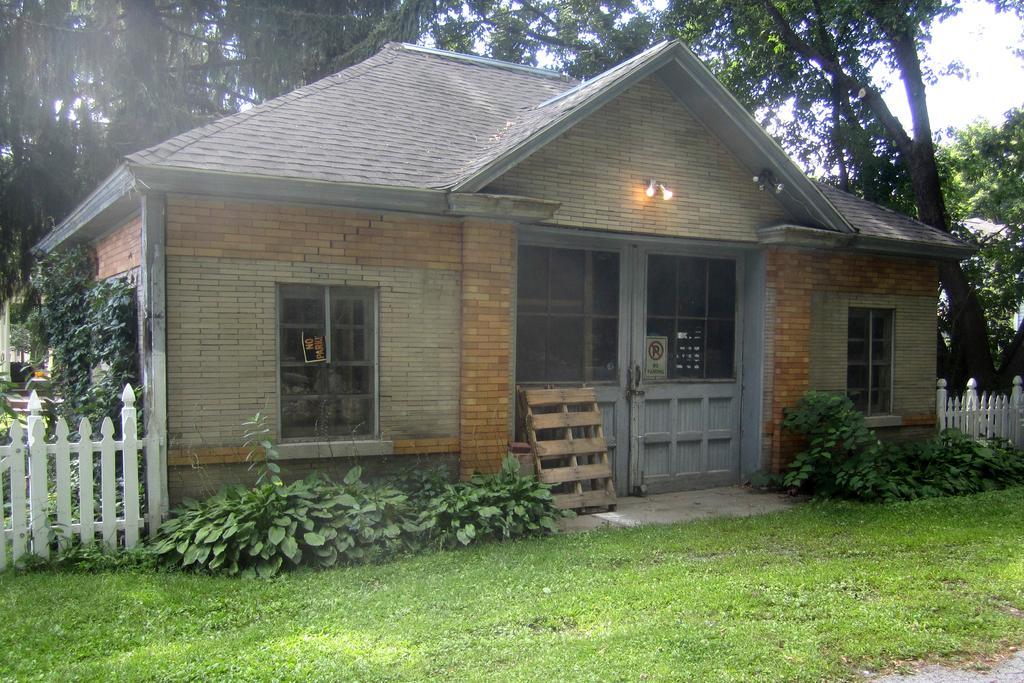In one or two sentences, can you explain what this image depicts? In this picture we can see a house and some plants on the path. There is a board and some lights on this house. We can see some fencing from left to right. Few trees are visible in the background. 